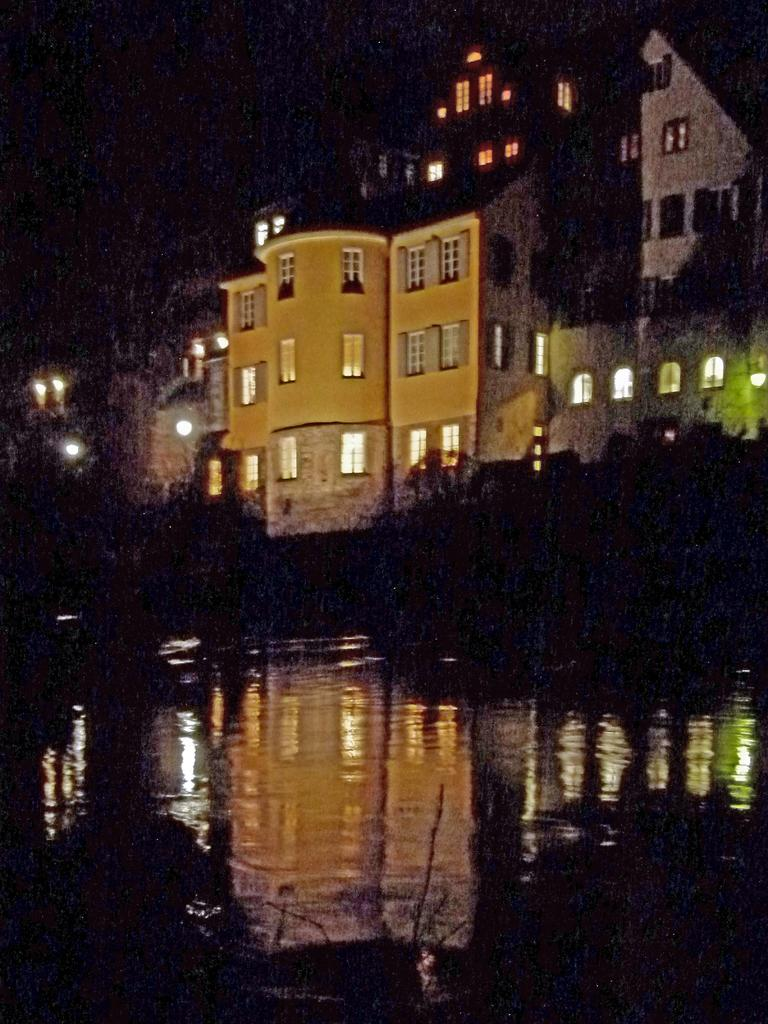What is the setting of the image? The image depicts a night view of buildings. What features can be observed on the buildings? The buildings have lights and windows. What additional elements are present in the image? There are plants and water visible in the image. What type of rule is being enforced by the plants in the image? There is no rule being enforced by the plants in the image, as plants do not have the ability to enforce rules. 